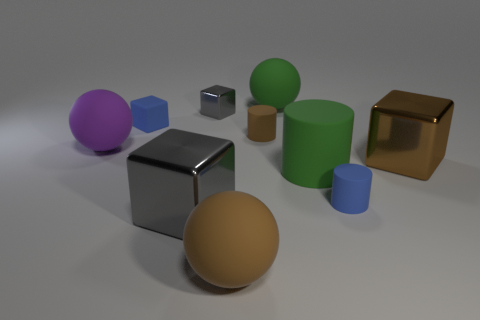Subtract all green blocks. Subtract all cyan cylinders. How many blocks are left? 4 Subtract all balls. How many objects are left? 7 Subtract all blue matte cylinders. Subtract all gray shiny things. How many objects are left? 7 Add 8 big green rubber cylinders. How many big green rubber cylinders are left? 9 Add 6 small red objects. How many small red objects exist? 6 Subtract 0 red cylinders. How many objects are left? 10 